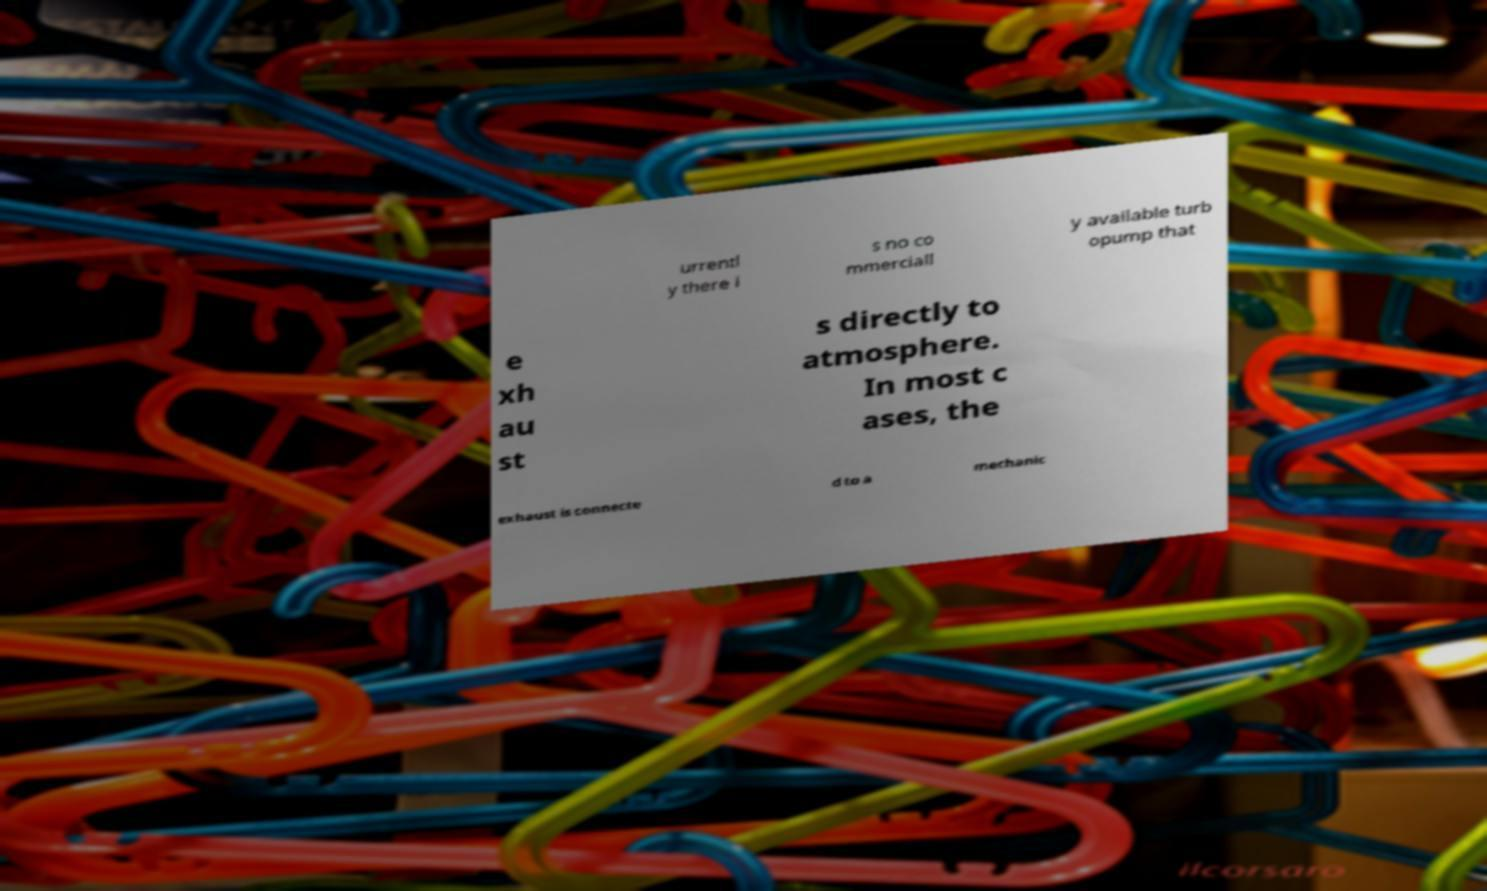Can you accurately transcribe the text from the provided image for me? urrentl y there i s no co mmerciall y available turb opump that e xh au st s directly to atmosphere. In most c ases, the exhaust is connecte d to a mechanic 